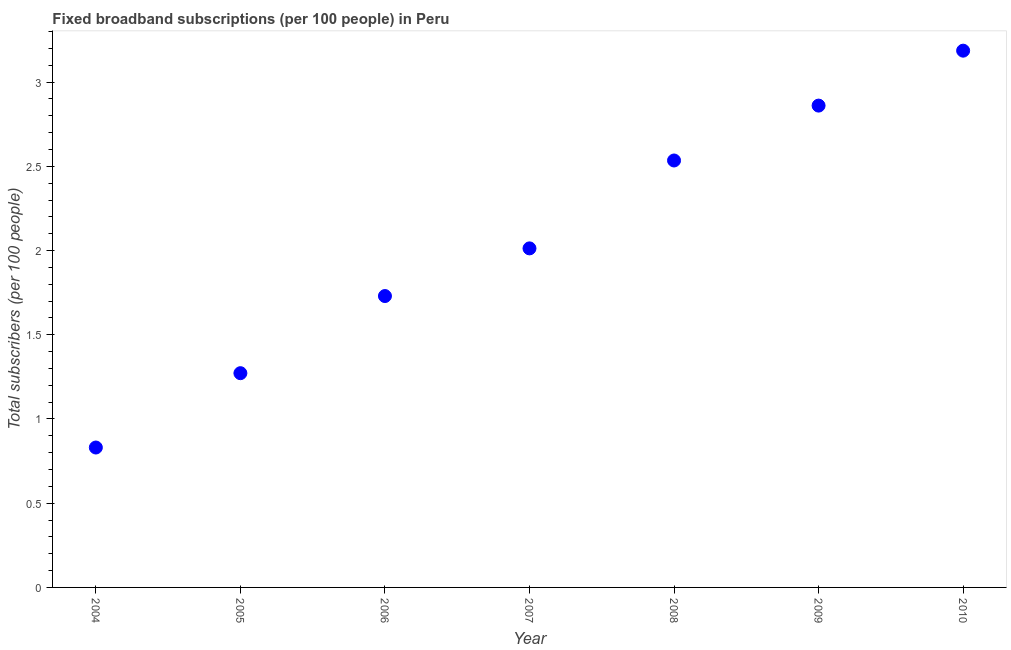What is the total number of fixed broadband subscriptions in 2007?
Offer a terse response. 2.01. Across all years, what is the maximum total number of fixed broadband subscriptions?
Give a very brief answer. 3.19. Across all years, what is the minimum total number of fixed broadband subscriptions?
Your response must be concise. 0.83. In which year was the total number of fixed broadband subscriptions maximum?
Your answer should be compact. 2010. In which year was the total number of fixed broadband subscriptions minimum?
Provide a short and direct response. 2004. What is the sum of the total number of fixed broadband subscriptions?
Provide a succinct answer. 14.43. What is the difference between the total number of fixed broadband subscriptions in 2004 and 2008?
Offer a very short reply. -1.7. What is the average total number of fixed broadband subscriptions per year?
Keep it short and to the point. 2.06. What is the median total number of fixed broadband subscriptions?
Your response must be concise. 2.01. In how many years, is the total number of fixed broadband subscriptions greater than 1.6 ?
Ensure brevity in your answer.  5. Do a majority of the years between 2009 and 2004 (inclusive) have total number of fixed broadband subscriptions greater than 2.3 ?
Provide a succinct answer. Yes. What is the ratio of the total number of fixed broadband subscriptions in 2007 to that in 2010?
Provide a short and direct response. 0.63. Is the difference between the total number of fixed broadband subscriptions in 2005 and 2007 greater than the difference between any two years?
Offer a terse response. No. What is the difference between the highest and the second highest total number of fixed broadband subscriptions?
Offer a very short reply. 0.33. What is the difference between the highest and the lowest total number of fixed broadband subscriptions?
Keep it short and to the point. 2.36. In how many years, is the total number of fixed broadband subscriptions greater than the average total number of fixed broadband subscriptions taken over all years?
Offer a very short reply. 3. Does the total number of fixed broadband subscriptions monotonically increase over the years?
Offer a very short reply. Yes. Are the values on the major ticks of Y-axis written in scientific E-notation?
Offer a very short reply. No. What is the title of the graph?
Make the answer very short. Fixed broadband subscriptions (per 100 people) in Peru. What is the label or title of the Y-axis?
Offer a very short reply. Total subscribers (per 100 people). What is the Total subscribers (per 100 people) in 2004?
Keep it short and to the point. 0.83. What is the Total subscribers (per 100 people) in 2005?
Keep it short and to the point. 1.27. What is the Total subscribers (per 100 people) in 2006?
Give a very brief answer. 1.73. What is the Total subscribers (per 100 people) in 2007?
Ensure brevity in your answer.  2.01. What is the Total subscribers (per 100 people) in 2008?
Ensure brevity in your answer.  2.53. What is the Total subscribers (per 100 people) in 2009?
Your response must be concise. 2.86. What is the Total subscribers (per 100 people) in 2010?
Give a very brief answer. 3.19. What is the difference between the Total subscribers (per 100 people) in 2004 and 2005?
Offer a terse response. -0.44. What is the difference between the Total subscribers (per 100 people) in 2004 and 2006?
Provide a succinct answer. -0.9. What is the difference between the Total subscribers (per 100 people) in 2004 and 2007?
Give a very brief answer. -1.18. What is the difference between the Total subscribers (per 100 people) in 2004 and 2008?
Offer a very short reply. -1.7. What is the difference between the Total subscribers (per 100 people) in 2004 and 2009?
Your response must be concise. -2.03. What is the difference between the Total subscribers (per 100 people) in 2004 and 2010?
Keep it short and to the point. -2.36. What is the difference between the Total subscribers (per 100 people) in 2005 and 2006?
Offer a very short reply. -0.46. What is the difference between the Total subscribers (per 100 people) in 2005 and 2007?
Keep it short and to the point. -0.74. What is the difference between the Total subscribers (per 100 people) in 2005 and 2008?
Your response must be concise. -1.26. What is the difference between the Total subscribers (per 100 people) in 2005 and 2009?
Your answer should be very brief. -1.59. What is the difference between the Total subscribers (per 100 people) in 2005 and 2010?
Provide a succinct answer. -1.91. What is the difference between the Total subscribers (per 100 people) in 2006 and 2007?
Your response must be concise. -0.28. What is the difference between the Total subscribers (per 100 people) in 2006 and 2008?
Your response must be concise. -0.8. What is the difference between the Total subscribers (per 100 people) in 2006 and 2009?
Your response must be concise. -1.13. What is the difference between the Total subscribers (per 100 people) in 2006 and 2010?
Offer a terse response. -1.46. What is the difference between the Total subscribers (per 100 people) in 2007 and 2008?
Offer a very short reply. -0.52. What is the difference between the Total subscribers (per 100 people) in 2007 and 2009?
Keep it short and to the point. -0.85. What is the difference between the Total subscribers (per 100 people) in 2007 and 2010?
Keep it short and to the point. -1.17. What is the difference between the Total subscribers (per 100 people) in 2008 and 2009?
Make the answer very short. -0.33. What is the difference between the Total subscribers (per 100 people) in 2008 and 2010?
Your answer should be compact. -0.65. What is the difference between the Total subscribers (per 100 people) in 2009 and 2010?
Make the answer very short. -0.33. What is the ratio of the Total subscribers (per 100 people) in 2004 to that in 2005?
Offer a very short reply. 0.65. What is the ratio of the Total subscribers (per 100 people) in 2004 to that in 2006?
Your response must be concise. 0.48. What is the ratio of the Total subscribers (per 100 people) in 2004 to that in 2007?
Give a very brief answer. 0.41. What is the ratio of the Total subscribers (per 100 people) in 2004 to that in 2008?
Your answer should be very brief. 0.33. What is the ratio of the Total subscribers (per 100 people) in 2004 to that in 2009?
Your answer should be very brief. 0.29. What is the ratio of the Total subscribers (per 100 people) in 2004 to that in 2010?
Make the answer very short. 0.26. What is the ratio of the Total subscribers (per 100 people) in 2005 to that in 2006?
Keep it short and to the point. 0.73. What is the ratio of the Total subscribers (per 100 people) in 2005 to that in 2007?
Offer a terse response. 0.63. What is the ratio of the Total subscribers (per 100 people) in 2005 to that in 2008?
Make the answer very short. 0.5. What is the ratio of the Total subscribers (per 100 people) in 2005 to that in 2009?
Your answer should be very brief. 0.45. What is the ratio of the Total subscribers (per 100 people) in 2005 to that in 2010?
Keep it short and to the point. 0.4. What is the ratio of the Total subscribers (per 100 people) in 2006 to that in 2007?
Your response must be concise. 0.86. What is the ratio of the Total subscribers (per 100 people) in 2006 to that in 2008?
Keep it short and to the point. 0.68. What is the ratio of the Total subscribers (per 100 people) in 2006 to that in 2009?
Your answer should be compact. 0.6. What is the ratio of the Total subscribers (per 100 people) in 2006 to that in 2010?
Offer a very short reply. 0.54. What is the ratio of the Total subscribers (per 100 people) in 2007 to that in 2008?
Make the answer very short. 0.79. What is the ratio of the Total subscribers (per 100 people) in 2007 to that in 2009?
Your answer should be compact. 0.7. What is the ratio of the Total subscribers (per 100 people) in 2007 to that in 2010?
Provide a succinct answer. 0.63. What is the ratio of the Total subscribers (per 100 people) in 2008 to that in 2009?
Your answer should be compact. 0.89. What is the ratio of the Total subscribers (per 100 people) in 2008 to that in 2010?
Your answer should be compact. 0.8. What is the ratio of the Total subscribers (per 100 people) in 2009 to that in 2010?
Your response must be concise. 0.9. 